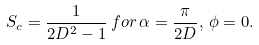<formula> <loc_0><loc_0><loc_500><loc_500>S _ { c } = \frac { 1 } { 2 D ^ { 2 } - 1 } \, f o r \, \alpha = \frac { \pi } { 2 D } , \, \phi = 0 .</formula> 